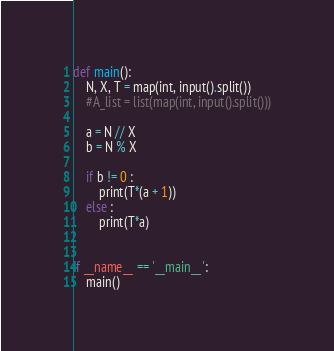<code> <loc_0><loc_0><loc_500><loc_500><_Python_>def main():
    N, X, T = map(int, input().split())
    #A_list = list(map(int, input().split()))

    a = N // X
    b = N % X

    if b != 0 :
        print(T*(a + 1))
    else :
        print(T*a)


if __name__ == '__main__':
    main()
</code> 